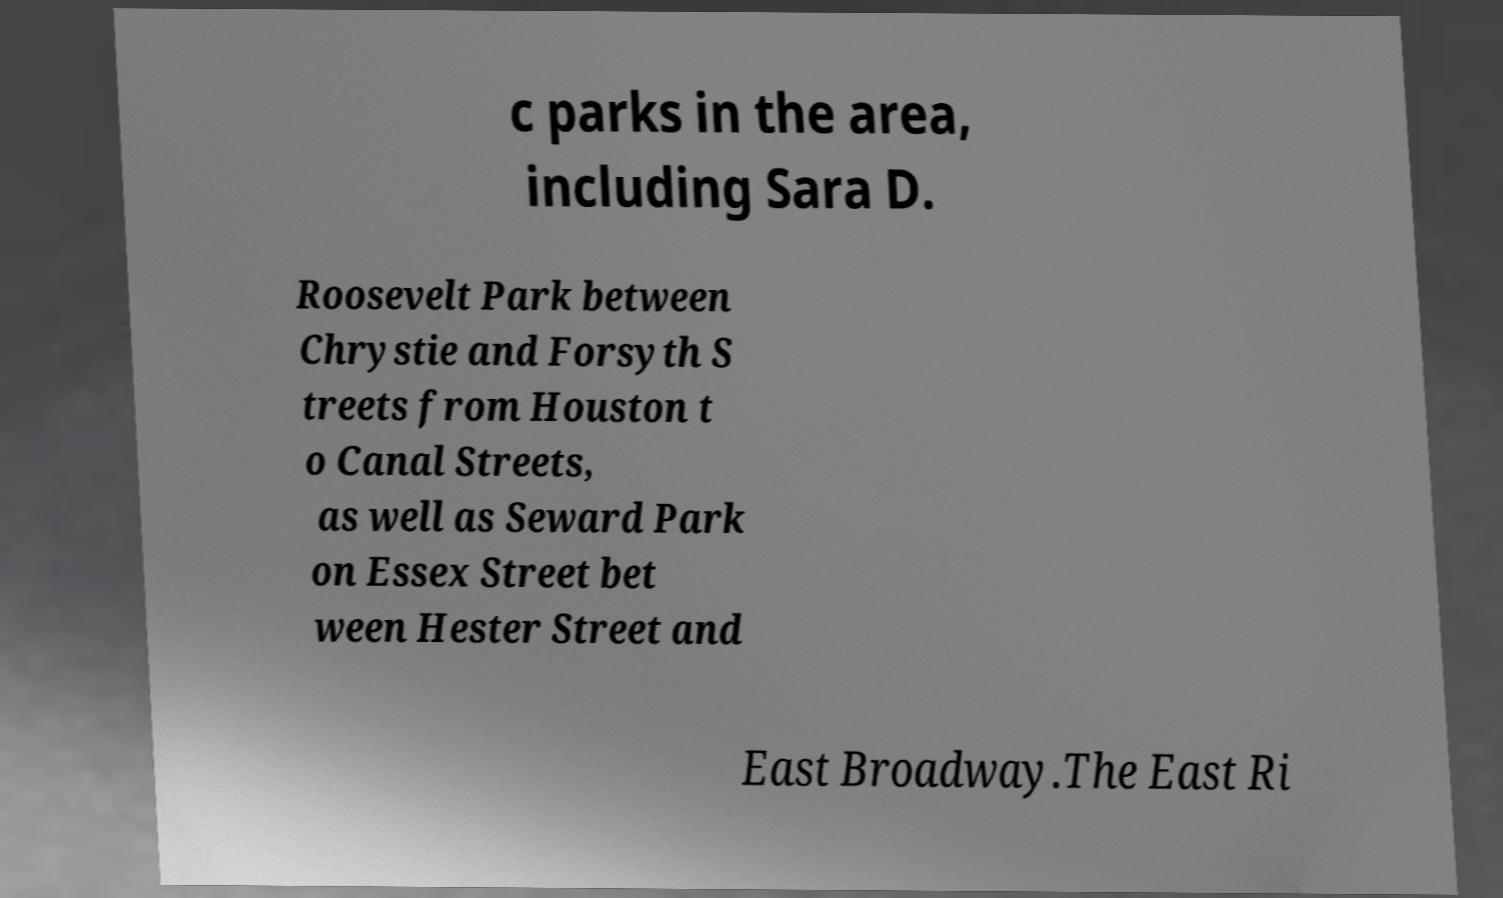What messages or text are displayed in this image? I need them in a readable, typed format. c parks in the area, including Sara D. Roosevelt Park between Chrystie and Forsyth S treets from Houston t o Canal Streets, as well as Seward Park on Essex Street bet ween Hester Street and East Broadway.The East Ri 